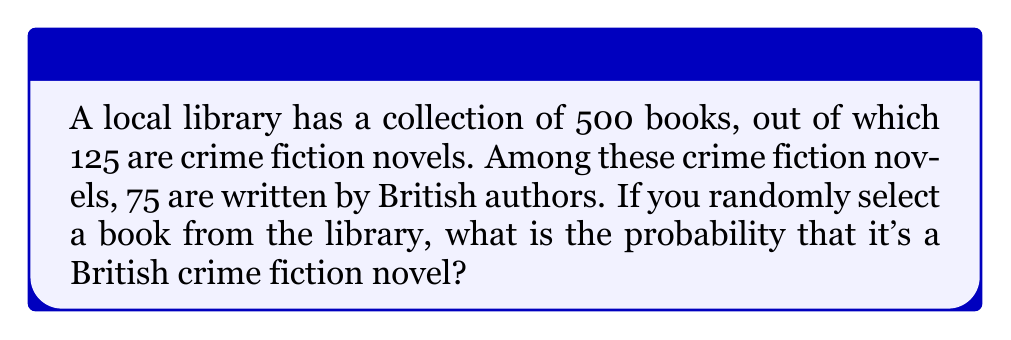Can you solve this math problem? Let's approach this step-by-step:

1. First, we need to identify the total number of books and the number of British crime fiction books:
   - Total books: 500
   - British crime fiction books: 75

2. The probability of an event is calculated by dividing the number of favorable outcomes by the total number of possible outcomes:

   $$P(\text{event}) = \frac{\text{favorable outcomes}}{\text{total outcomes}}$$

3. In this case:
   - Favorable outcomes: 75 (British crime fiction books)
   - Total outcomes: 500 (total books in the library)

4. Let's substitute these values into our probability formula:

   $$P(\text{British crime fiction}) = \frac{75}{500}$$

5. Simplify the fraction:

   $$P(\text{British crime fiction}) = \frac{3}{20} = 0.15$$

6. Convert to a percentage:

   $$0.15 \times 100\% = 15\%$$

Therefore, the probability of randomly selecting a British crime fiction book from this library is 15% or 0.15.
Answer: $\frac{3}{20}$ or $0.15$ or $15\%$ 